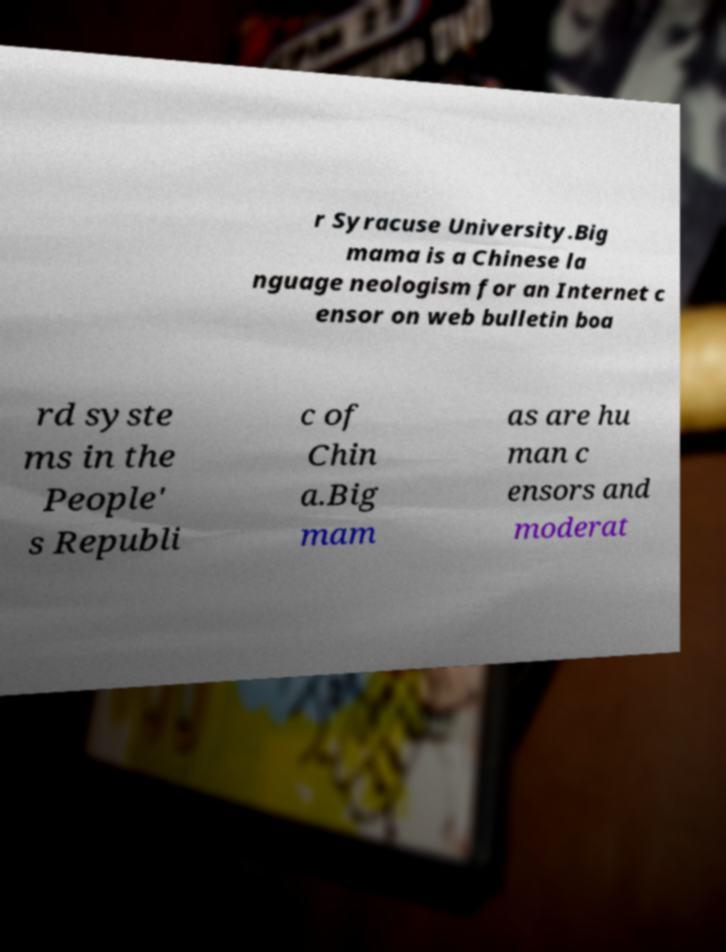Can you accurately transcribe the text from the provided image for me? r Syracuse University.Big mama is a Chinese la nguage neologism for an Internet c ensor on web bulletin boa rd syste ms in the People' s Republi c of Chin a.Big mam as are hu man c ensors and moderat 